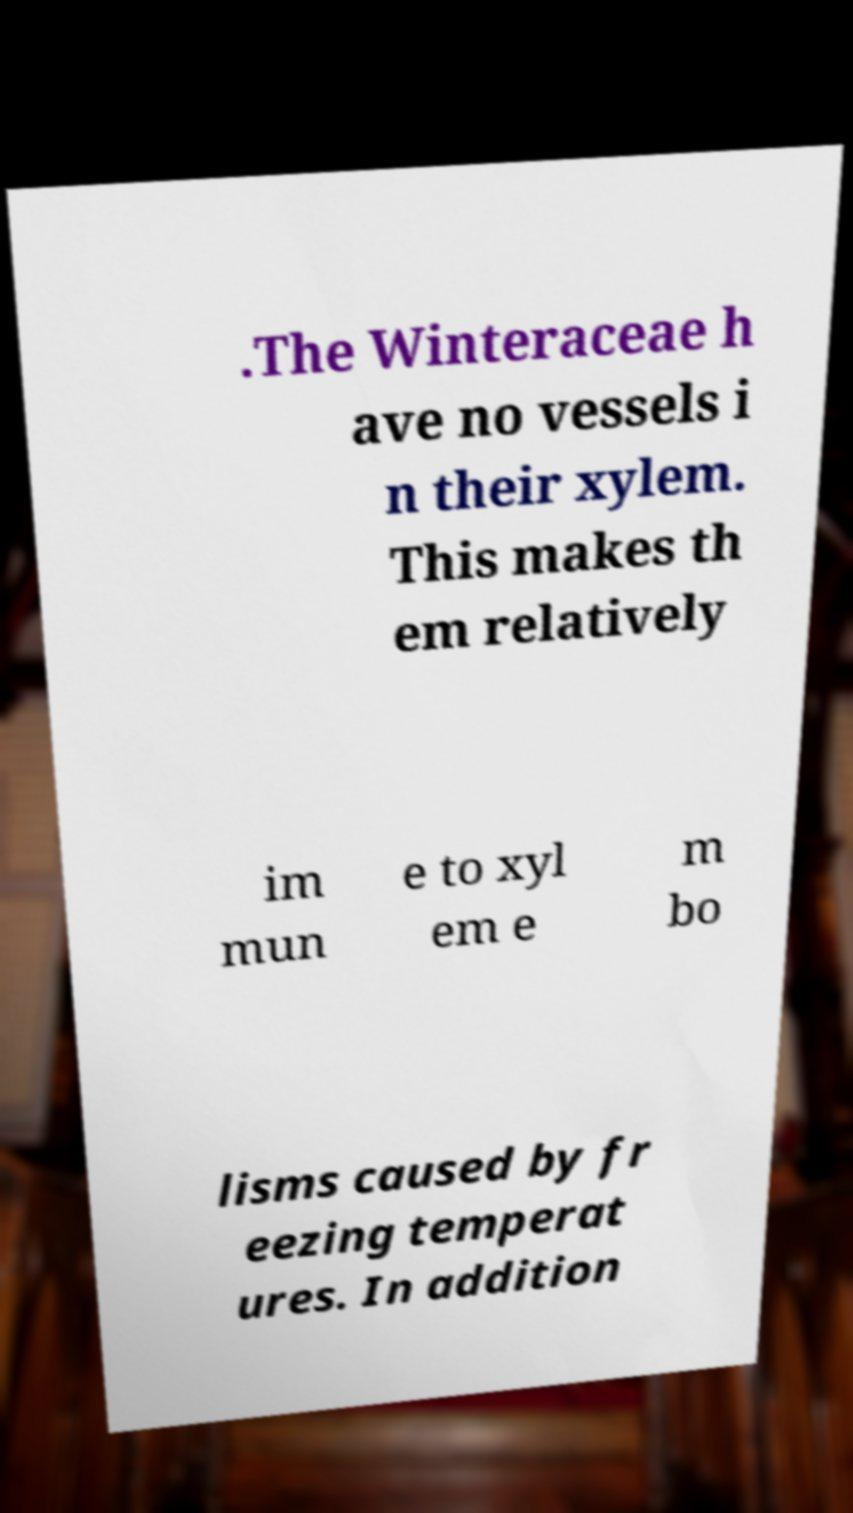Can you accurately transcribe the text from the provided image for me? .The Winteraceae h ave no vessels i n their xylem. This makes th em relatively im mun e to xyl em e m bo lisms caused by fr eezing temperat ures. In addition 